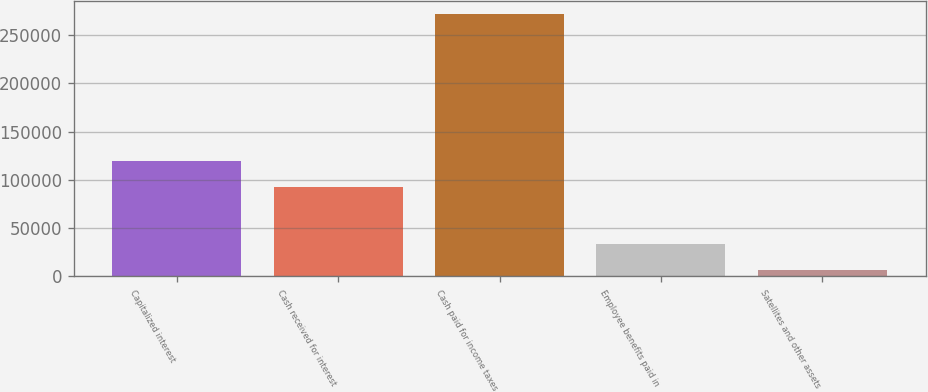Convert chart to OTSL. <chart><loc_0><loc_0><loc_500><loc_500><bar_chart><fcel>Capitalized interest<fcel>Cash received for interest<fcel>Cash paid for income taxes<fcel>Employee benefits paid in<fcel>Satellites and other assets<nl><fcel>119326<fcel>92770<fcel>272266<fcel>33262.9<fcel>6707<nl></chart> 